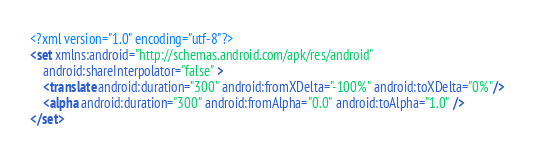<code> <loc_0><loc_0><loc_500><loc_500><_XML_><?xml version="1.0" encoding="utf-8"?>
<set xmlns:android="http://schemas.android.com/apk/res/android"
    android:shareInterpolator="false" >
    <translate android:duration="300" android:fromXDelta="-100%" android:toXDelta="0%"/>
    <alpha android:duration="300" android:fromAlpha="0.0" android:toAlpha="1.0" />
</set></code> 